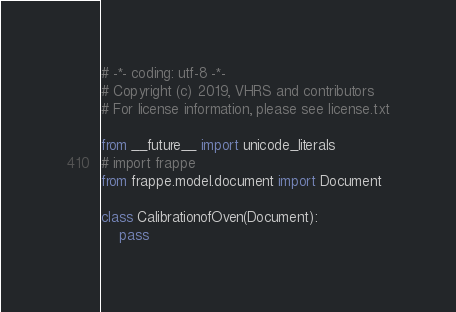<code> <loc_0><loc_0><loc_500><loc_500><_Python_># -*- coding: utf-8 -*-
# Copyright (c) 2019, VHRS and contributors
# For license information, please see license.txt

from __future__ import unicode_literals
# import frappe
from frappe.model.document import Document

class CalibrationofOven(Document):
	pass
</code> 